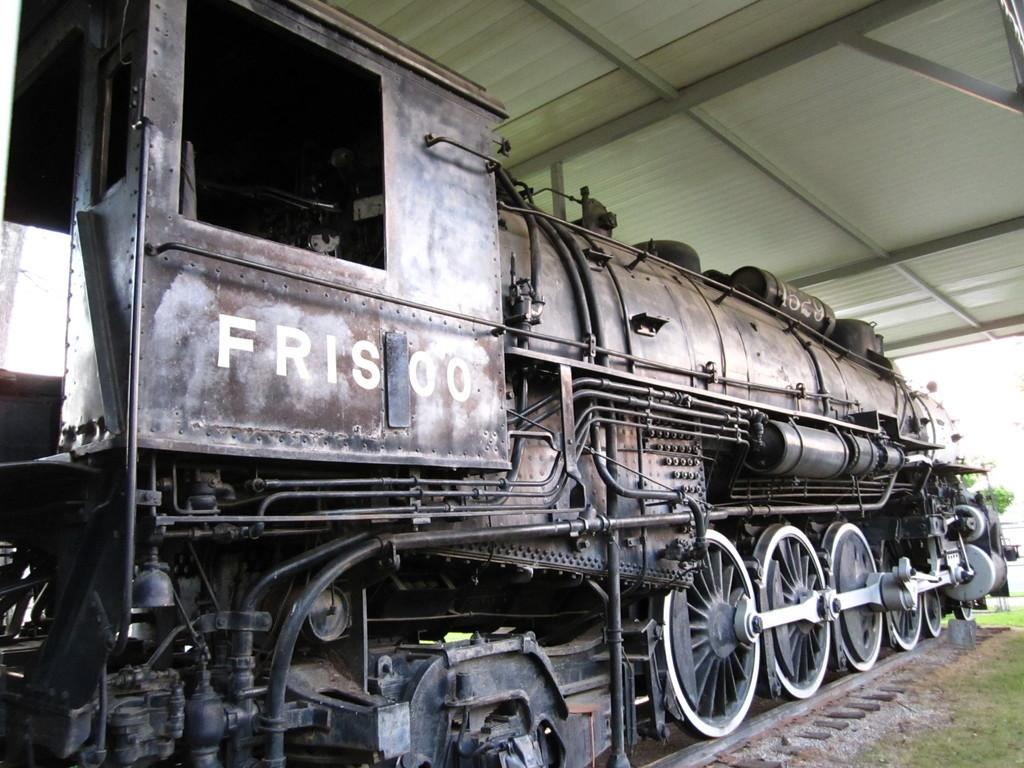What is the main subject in the center of the image? There is a train in the center of the image. What type of terrain is visible at the bottom of the image? There is grass at the bottom of the image. What is the train positioned on in the image? There is a railway track at the bottom of the image. What is visible at the top of the image? There is a ceiling at the top of the image, and there are poles present as well. What month does the father say good-bye to the train in the image? There is no father or good-bye in the image; it only features a train, grass, railway track, ceiling, and poles. 